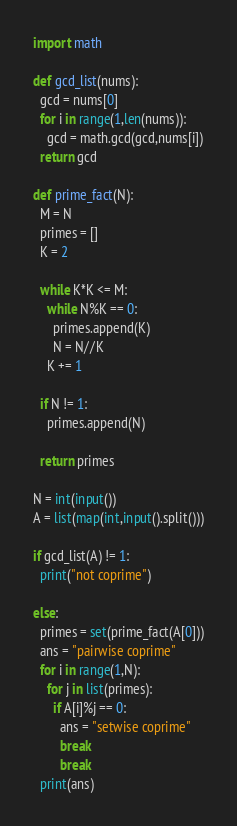<code> <loc_0><loc_0><loc_500><loc_500><_Python_>import math

def gcd_list(nums):
  gcd = nums[0]
  for i in range(1,len(nums)):
    gcd = math.gcd(gcd,nums[i])
  return gcd

def prime_fact(N):
  M = N
  primes = []
  K = 2

  while K*K <= M:
    while N%K == 0:
      primes.append(K)
      N = N//K
    K += 1
  
  if N != 1:
    primes.append(N)

  return primes

N = int(input())
A = list(map(int,input().split()))

if gcd_list(A) != 1:
  print("not coprime")
  
else:
  primes = set(prime_fact(A[0]))
  ans = "pairwise coprime"
  for i in range(1,N):
    for j in list(primes):
      if A[i]%j == 0:
        ans = "setwise coprime"
        break
        break
  print(ans)</code> 